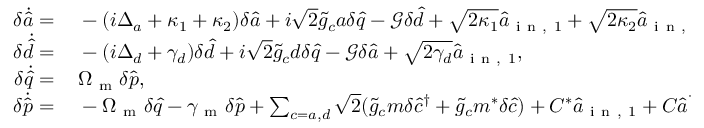<formula> <loc_0><loc_0><loc_500><loc_500>\begin{array} { r l } { \delta \dot { \hat { a } } = \, } & - ( i \Delta _ { a } + \kappa _ { 1 } + \kappa _ { 2 } ) \delta \hat { a } + i \sqrt { 2 } \tilde { g } _ { c } a \delta \hat { q } - \mathcal { G } \delta \hat { d } + \sqrt { 2 \kappa _ { 1 } } \hat { a } _ { i n , 1 } + \sqrt { 2 \kappa _ { 2 } } \hat { a } _ { i n , 2 } , } \\ { \delta \dot { \hat { d } } = \, } & - ( i \Delta _ { d } + \gamma _ { d } ) \delta \hat { d } + i \sqrt { 2 } \tilde { g } _ { c } d \delta \hat { q } - \mathcal { G } \delta \hat { a } + \sqrt { 2 \gamma _ { d } } \hat { a } _ { i n , 1 } , } \\ { \delta \dot { \hat { q } } = \, } & \Omega _ { m } \delta \hat { p } , } \\ { \delta \dot { \hat { p } } = \, } & - \Omega _ { m } \delta \hat { q } - \gamma _ { m } \delta \hat { p } + \sum _ { c = a , d } \sqrt { 2 } ( \tilde { g } _ { c } m \delta \hat { c } ^ { \dagger } + \tilde { g } _ { c } m ^ { * } \delta \hat { c } ) + C ^ { * } \hat { a } _ { i n , 1 } + C \hat { a } _ { i n , 1 } ^ { \dagger } + \sqrt { \gamma _ { m } } \hat { \xi } , } \end{array}</formula> 